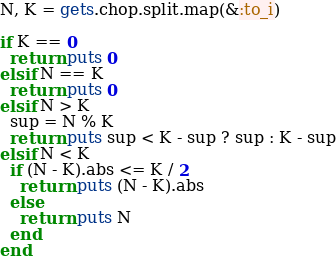Convert code to text. <code><loc_0><loc_0><loc_500><loc_500><_Ruby_>N, K = gets.chop.split.map(&:to_i)

if K == 0
  return puts 0
elsif N == K
  return puts 0
elsif N > K
  sup = N % K
  return puts sup < K - sup ? sup : K - sup
elsif N < K
  if (N - K).abs <= K / 2
    return puts (N - K).abs
  else
    return puts N
  end
end
</code> 